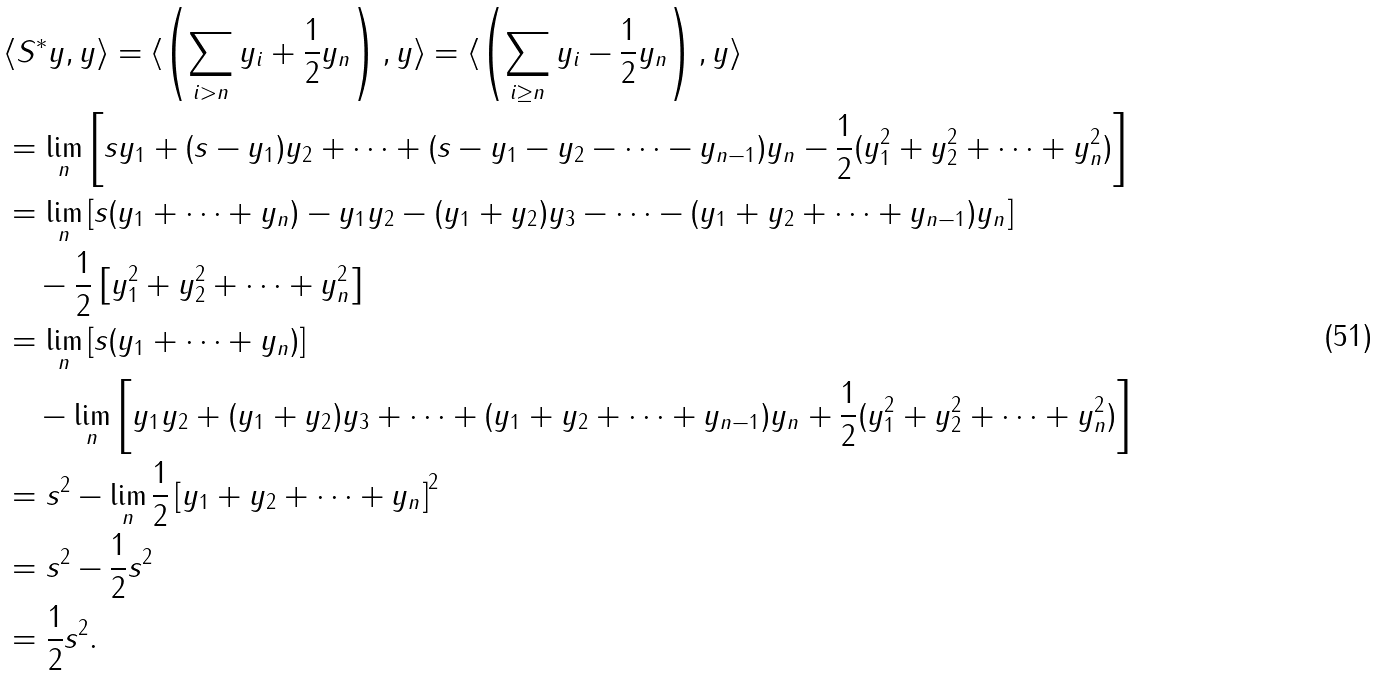<formula> <loc_0><loc_0><loc_500><loc_500>& \langle S ^ { * } y , y \rangle = \langle \left ( \sum _ { i > n } y _ { i } + \frac { 1 } { 2 } y _ { n } \right ) , y \rangle = \langle \left ( \sum _ { i \geq n } y _ { i } - \frac { 1 } { 2 } y _ { n } \right ) , y \rangle \\ & = \lim _ { n } \left [ s y _ { 1 } + ( s - y _ { 1 } ) y _ { 2 } + \cdots + ( s - y _ { 1 } - y _ { 2 } - \cdots - y _ { n - 1 } ) y _ { n } - \frac { 1 } { 2 } ( y ^ { 2 } _ { 1 } + y ^ { 2 } _ { 2 } + \cdots + y ^ { 2 } _ { n } ) \right ] \\ & = \lim _ { n } \left [ s ( y _ { 1 } + \cdots + y _ { n } ) - y _ { 1 } y _ { 2 } - ( y _ { 1 } + y _ { 2 } ) y _ { 3 } - \cdots - ( y _ { 1 } + y _ { 2 } + \cdots + y _ { n - 1 } ) y _ { n } \right ] \\ & \quad - \frac { 1 } { 2 } \left [ y ^ { 2 } _ { 1 } + y ^ { 2 } _ { 2 } + \cdots + y ^ { 2 } _ { n } \right ] \\ & = \lim _ { n } \left [ s ( y _ { 1 } + \cdots + y _ { n } ) \right ] \\ & \quad - \lim _ { n } \left [ y _ { 1 } y _ { 2 } + ( y _ { 1 } + y _ { 2 } ) y _ { 3 } + \cdots + ( y _ { 1 } + y _ { 2 } + \cdots + y _ { n - 1 } ) y _ { n } + \frac { 1 } { 2 } ( y ^ { 2 } _ { 1 } + y ^ { 2 } _ { 2 } + \cdots + y ^ { 2 } _ { n } ) \right ] \\ & = s ^ { 2 } - \lim _ { n } \frac { 1 } { 2 } \left [ y _ { 1 } + y _ { 2 } + \cdots + y _ { n } \right ] ^ { 2 } \\ & = s ^ { 2 } - \frac { 1 } { 2 } s ^ { 2 } \\ & = \frac { 1 } { 2 } s ^ { 2 } .</formula> 